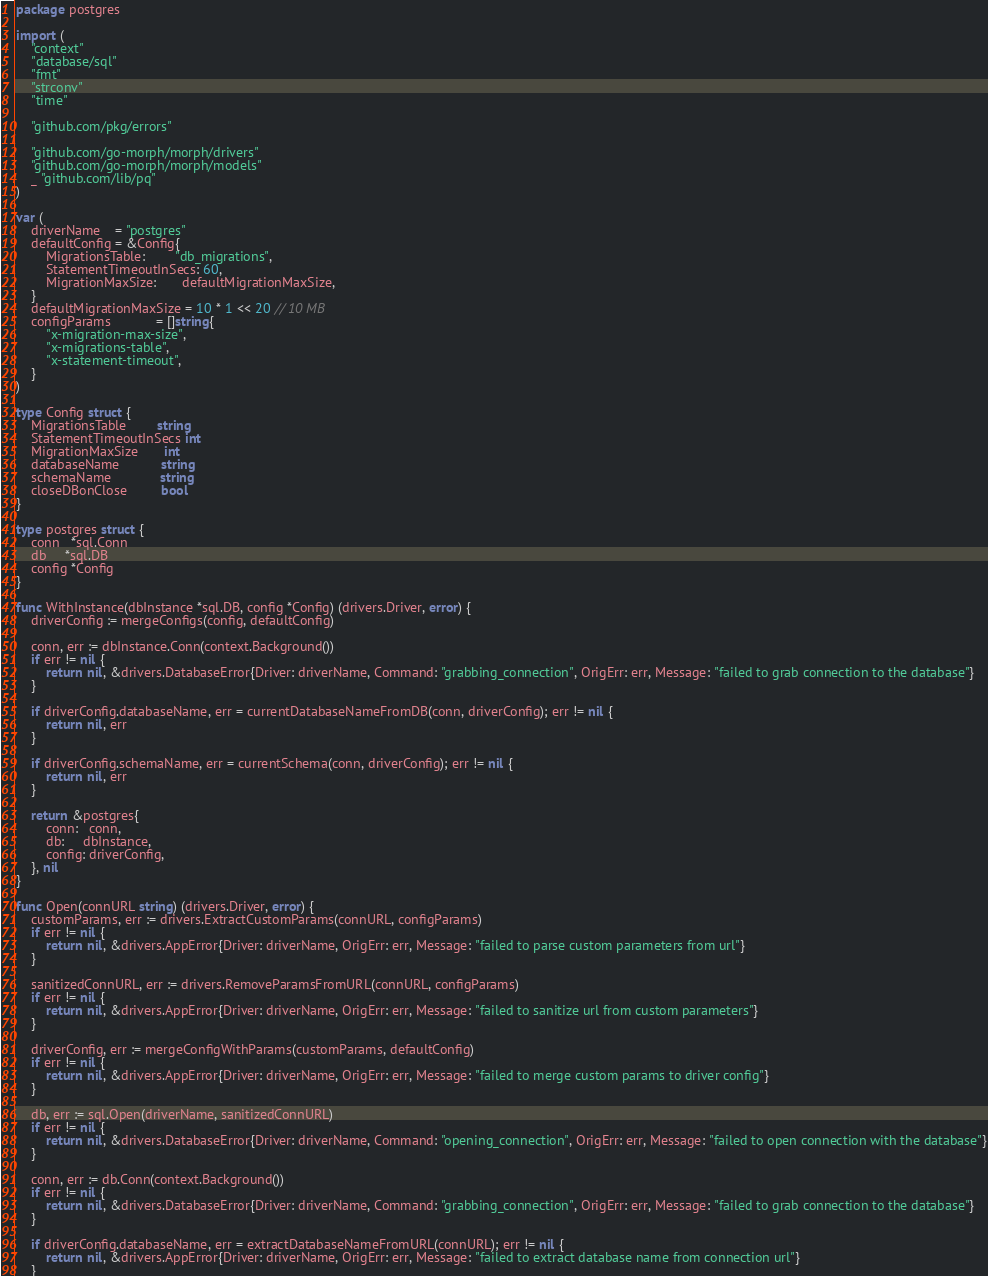Convert code to text. <code><loc_0><loc_0><loc_500><loc_500><_Go_>package postgres

import (
	"context"
	"database/sql"
	"fmt"
	"strconv"
	"time"

	"github.com/pkg/errors"

	"github.com/go-morph/morph/drivers"
	"github.com/go-morph/morph/models"
	_ "github.com/lib/pq"
)

var (
	driverName    = "postgres"
	defaultConfig = &Config{
		MigrationsTable:        "db_migrations",
		StatementTimeoutInSecs: 60,
		MigrationMaxSize:       defaultMigrationMaxSize,
	}
	defaultMigrationMaxSize = 10 * 1 << 20 // 10 MB
	configParams            = []string{
		"x-migration-max-size",
		"x-migrations-table",
		"x-statement-timeout",
	}
)

type Config struct {
	MigrationsTable        string
	StatementTimeoutInSecs int
	MigrationMaxSize       int
	databaseName           string
	schemaName             string
	closeDBonClose         bool
}

type postgres struct {
	conn   *sql.Conn
	db     *sql.DB
	config *Config
}

func WithInstance(dbInstance *sql.DB, config *Config) (drivers.Driver, error) {
	driverConfig := mergeConfigs(config, defaultConfig)

	conn, err := dbInstance.Conn(context.Background())
	if err != nil {
		return nil, &drivers.DatabaseError{Driver: driverName, Command: "grabbing_connection", OrigErr: err, Message: "failed to grab connection to the database"}
	}

	if driverConfig.databaseName, err = currentDatabaseNameFromDB(conn, driverConfig); err != nil {
		return nil, err
	}

	if driverConfig.schemaName, err = currentSchema(conn, driverConfig); err != nil {
		return nil, err
	}

	return &postgres{
		conn:   conn,
		db:     dbInstance,
		config: driverConfig,
	}, nil
}

func Open(connURL string) (drivers.Driver, error) {
	customParams, err := drivers.ExtractCustomParams(connURL, configParams)
	if err != nil {
		return nil, &drivers.AppError{Driver: driverName, OrigErr: err, Message: "failed to parse custom parameters from url"}
	}

	sanitizedConnURL, err := drivers.RemoveParamsFromURL(connURL, configParams)
	if err != nil {
		return nil, &drivers.AppError{Driver: driverName, OrigErr: err, Message: "failed to sanitize url from custom parameters"}
	}

	driverConfig, err := mergeConfigWithParams(customParams, defaultConfig)
	if err != nil {
		return nil, &drivers.AppError{Driver: driverName, OrigErr: err, Message: "failed to merge custom params to driver config"}
	}

	db, err := sql.Open(driverName, sanitizedConnURL)
	if err != nil {
		return nil, &drivers.DatabaseError{Driver: driverName, Command: "opening_connection", OrigErr: err, Message: "failed to open connection with the database"}
	}

	conn, err := db.Conn(context.Background())
	if err != nil {
		return nil, &drivers.DatabaseError{Driver: driverName, Command: "grabbing_connection", OrigErr: err, Message: "failed to grab connection to the database"}
	}

	if driverConfig.databaseName, err = extractDatabaseNameFromURL(connURL); err != nil {
		return nil, &drivers.AppError{Driver: driverName, OrigErr: err, Message: "failed to extract database name from connection url"}
	}
</code> 